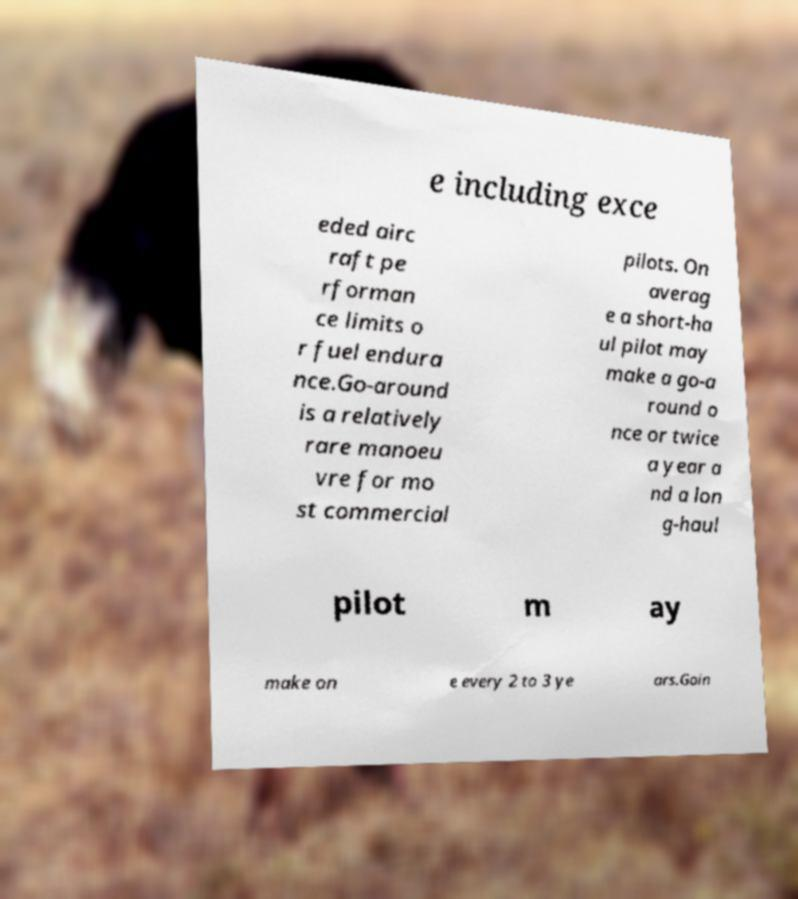Can you read and provide the text displayed in the image?This photo seems to have some interesting text. Can you extract and type it out for me? e including exce eded airc raft pe rforman ce limits o r fuel endura nce.Go-around is a relatively rare manoeu vre for mo st commercial pilots. On averag e a short-ha ul pilot may make a go-a round o nce or twice a year a nd a lon g-haul pilot m ay make on e every 2 to 3 ye ars.Goin 